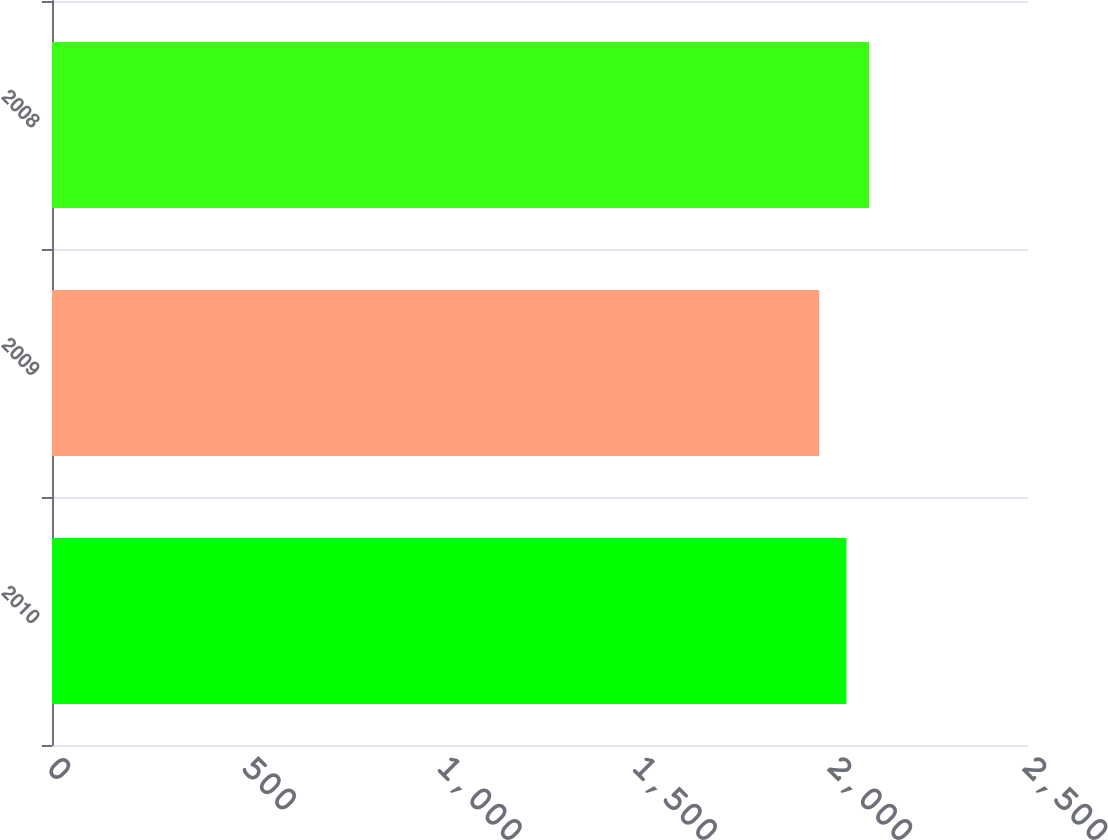Convert chart. <chart><loc_0><loc_0><loc_500><loc_500><bar_chart><fcel>2010<fcel>2009<fcel>2008<nl><fcel>2035<fcel>1965<fcel>2093<nl></chart> 